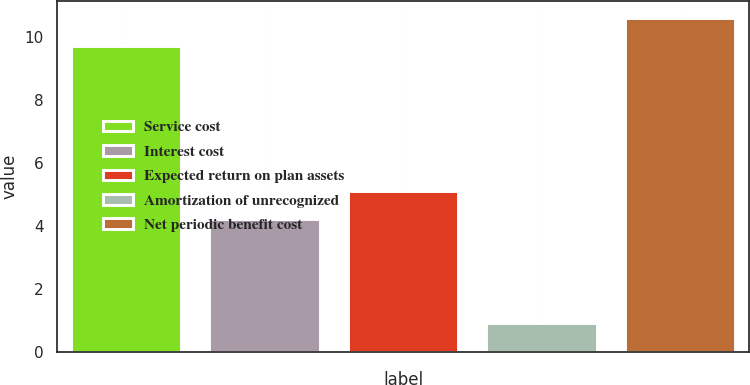<chart> <loc_0><loc_0><loc_500><loc_500><bar_chart><fcel>Service cost<fcel>Interest cost<fcel>Expected return on plan assets<fcel>Amortization of unrecognized<fcel>Net periodic benefit cost<nl><fcel>9.7<fcel>4.2<fcel>5.1<fcel>0.9<fcel>10.6<nl></chart> 